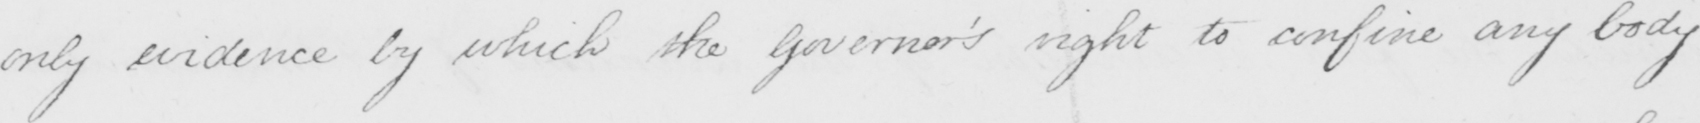Can you read and transcribe this handwriting? only evidence by which the Governor ' s right to confine any body 